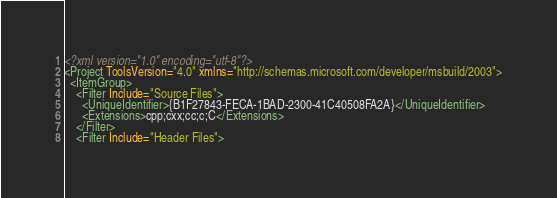<code> <loc_0><loc_0><loc_500><loc_500><_XML_><?xml version="1.0" encoding="utf-8"?>
<Project ToolsVersion="4.0" xmlns="http://schemas.microsoft.com/developer/msbuild/2003">
  <ItemGroup>
    <Filter Include="Source Files">
      <UniqueIdentifier>{B1F27843-FECA-1BAD-2300-41C40508FA2A}</UniqueIdentifier>
      <Extensions>cpp;cxx;cc;c;C</Extensions>
    </Filter>
    <Filter Include="Header Files"></code> 